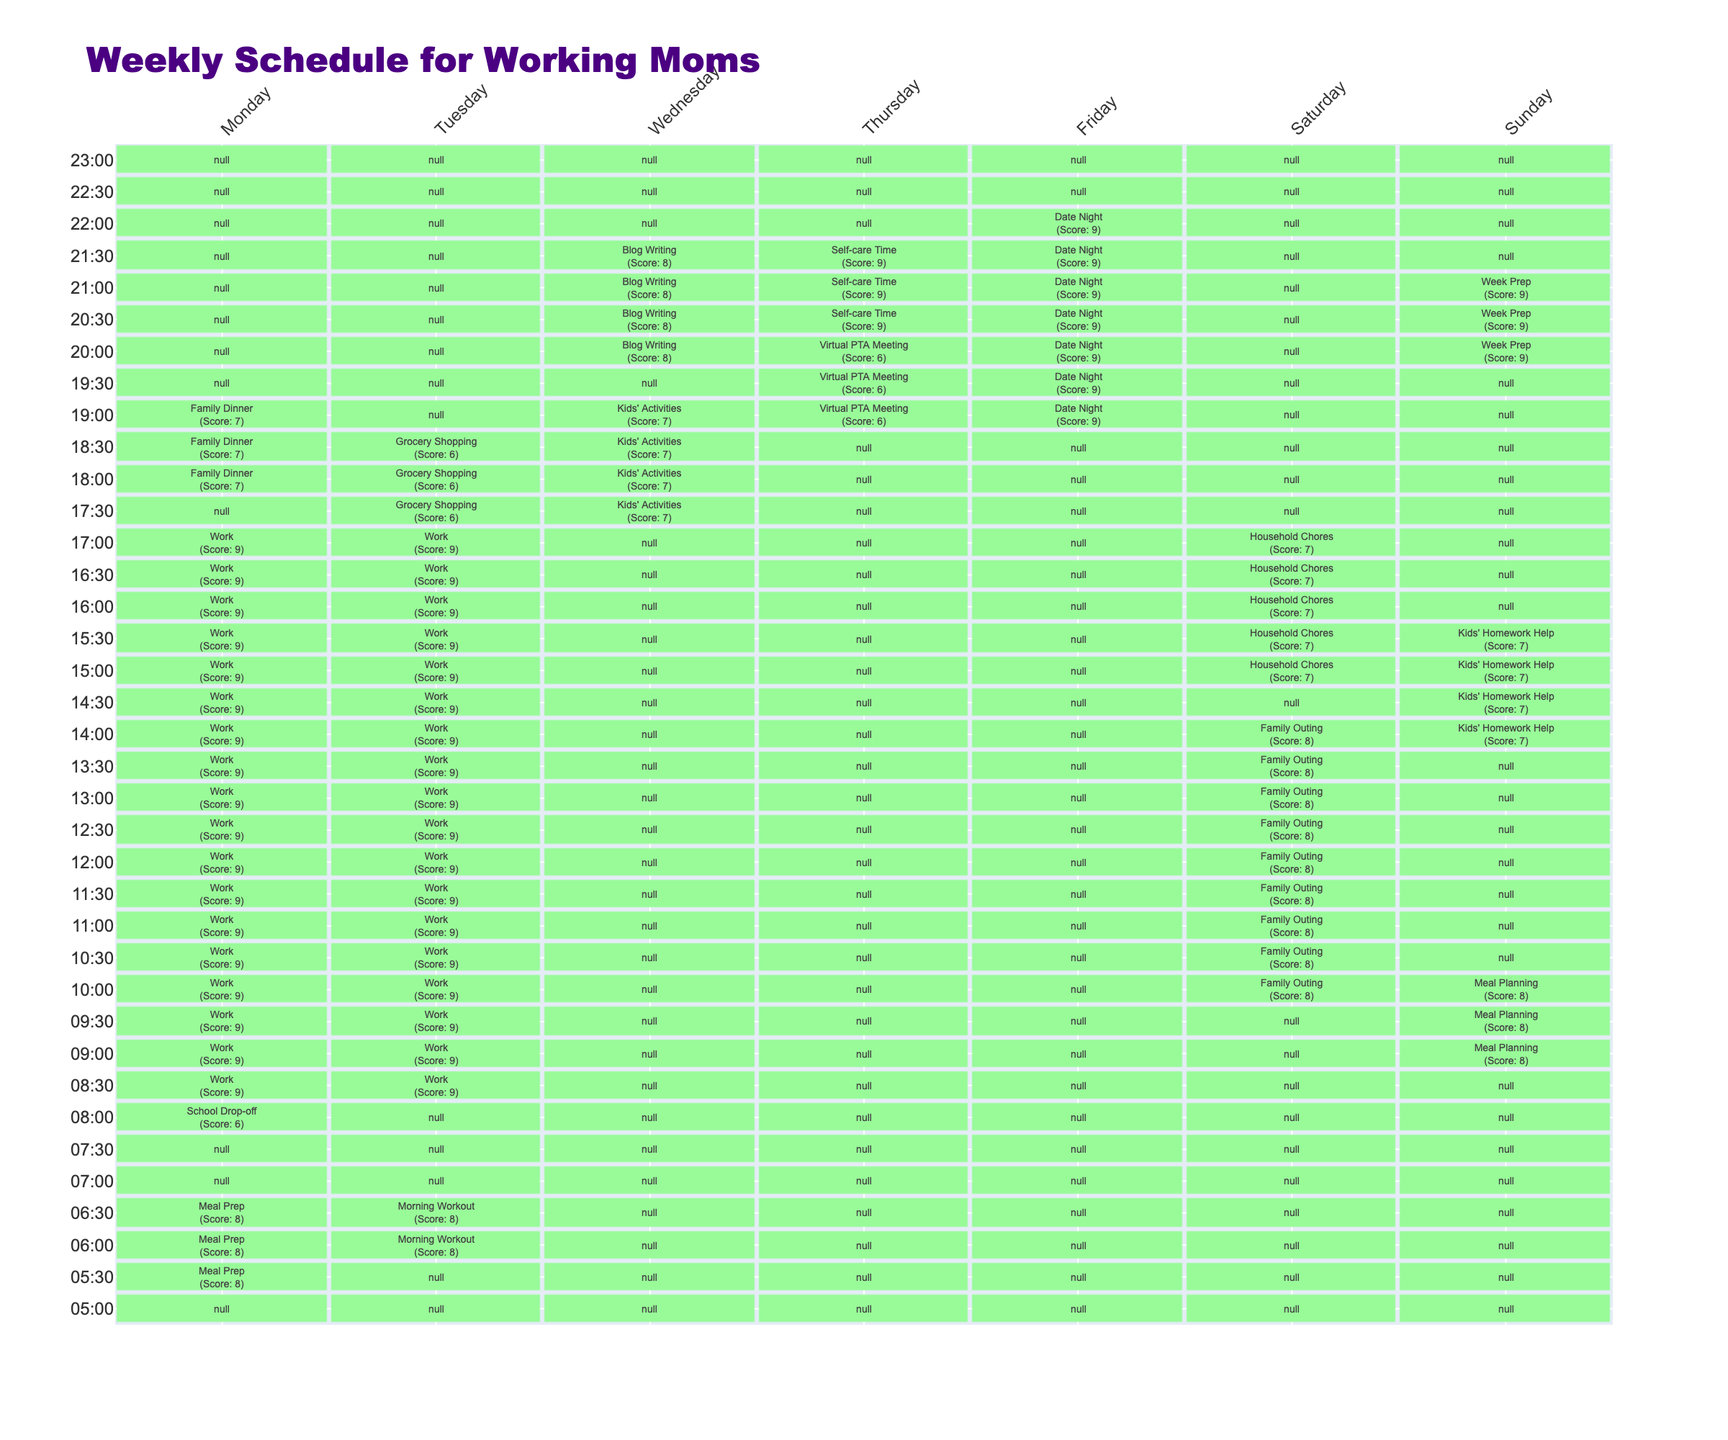What is the total duration of activities scheduled on Wednesday? The activities on Wednesday are "Kids' Activities" for 90 minutes and "Blog Writing" for another 90 minutes. Summing these durations gives 90 + 90 = 180 minutes.
Answer: 180 minutes Which activity has the highest productivity score, and what is that score? By looking through the table, the activities with the highest productivity score are "Work" on Monday and Tuesday, and "Date Night" on Friday, all scoring 9.
Answer: Date Night, score 9 Does any day have a productivity score lower than 6? Checking the productivity scores of activities for each day, "Grocery Shopping" on Tuesday and "Virtual PTA Meeting" on Thursday both have scores of 6. Thus, no activity has a score lower than this.
Answer: No On which day is the self-care time scheduled, and what is its duration? The "Self-care Time" activity is scheduled on Thursday, from 20:30 to 21:30, which is a duration of 60 minutes.
Answer: Thursday, 60 minutes What is the average productivity score for all activities on Saturday? The activities on Saturday are "Family Outing" with a score of 8 and "Household Chores" with a score of 7. The average score is (8 + 7) / 2 = 7.5.
Answer: 7.5 How many total minutes are allocated for work activities across the week? The work activities include "Work" on Monday (510 minutes) and Tuesday (510 minutes), totaling 1020 minutes.
Answer: 1020 minutes Is the time for "Kids' Homework Help" scheduled before or after 3 PM on Sunday? The "Kids' Homework Help" activity starts at 14:00 and ends at 15:30, which is before 3 PM.
Answer: Before 3 PM Which day has the most distinct scheduled activities, and how many are there? By counting the distinct scheduled activities for each day, Saturday has 2 activities ("Family Outing" and "Household Chores"), which is less than the other days that have more scheduled events. Tuesday has more scheduled activities than Saturday.
Answer: Tuesday, 3 activities What is the difference in productivity score between Monday's work and Friday's date night? Monday's work has a productivity score of 9, and Friday's date night also has a score of 9. Therefore, the difference in scores is 9 - 9 = 0.
Answer: 0 On which day is the longest single activity scheduled, and what is its duration? The longest activity "Date Night" on Friday lasts for 180 minutes, which is longer than any other scheduled activity.
Answer: Friday, 180 minutes 